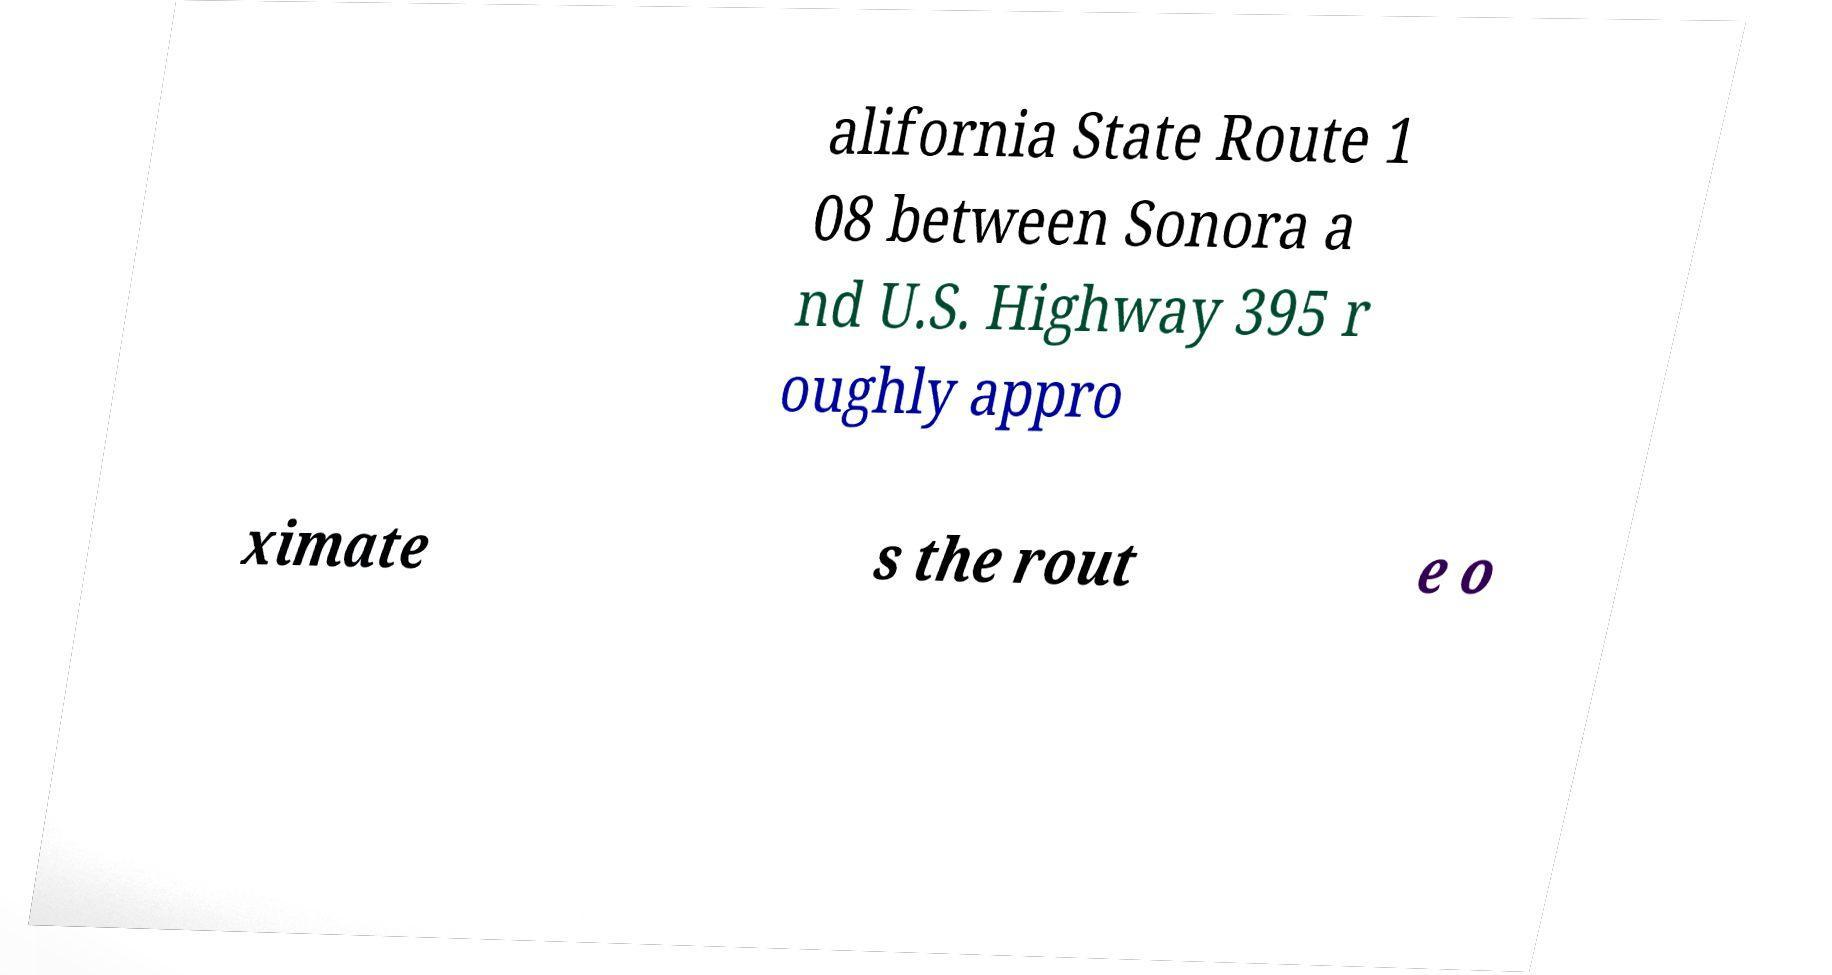I need the written content from this picture converted into text. Can you do that? alifornia State Route 1 08 between Sonora a nd U.S. Highway 395 r oughly appro ximate s the rout e o 